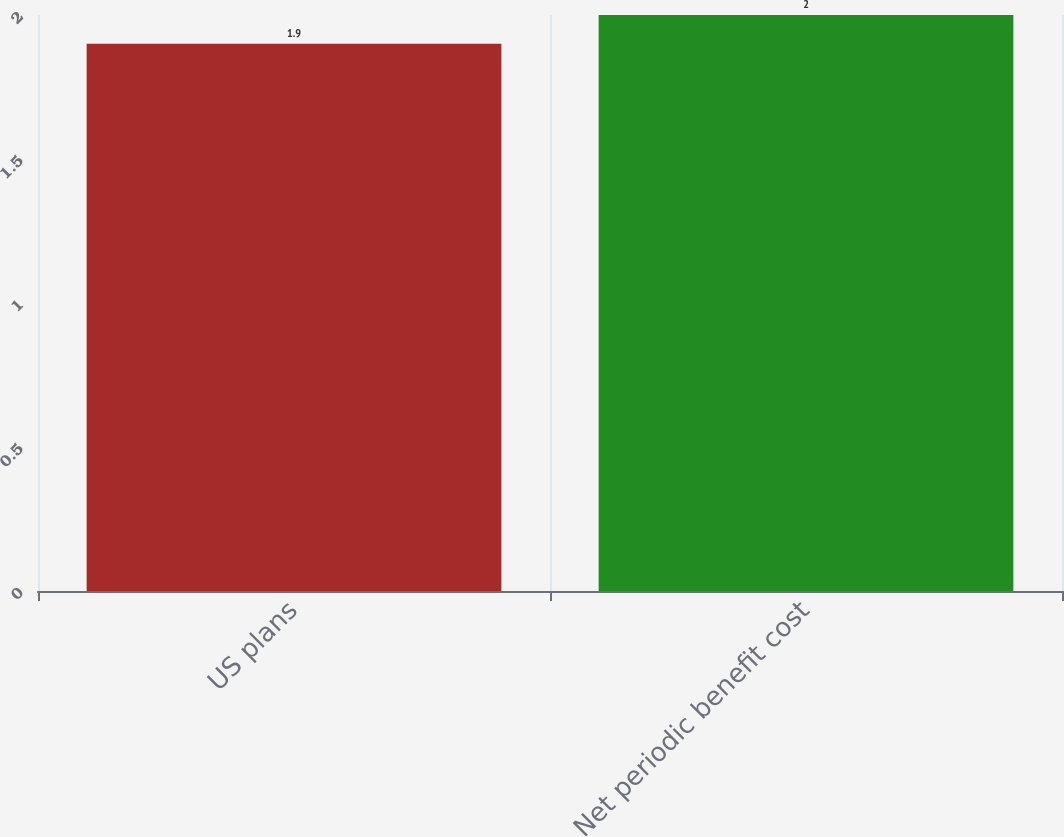<chart> <loc_0><loc_0><loc_500><loc_500><bar_chart><fcel>US plans<fcel>Net periodic benefit cost<nl><fcel>1.9<fcel>2<nl></chart> 